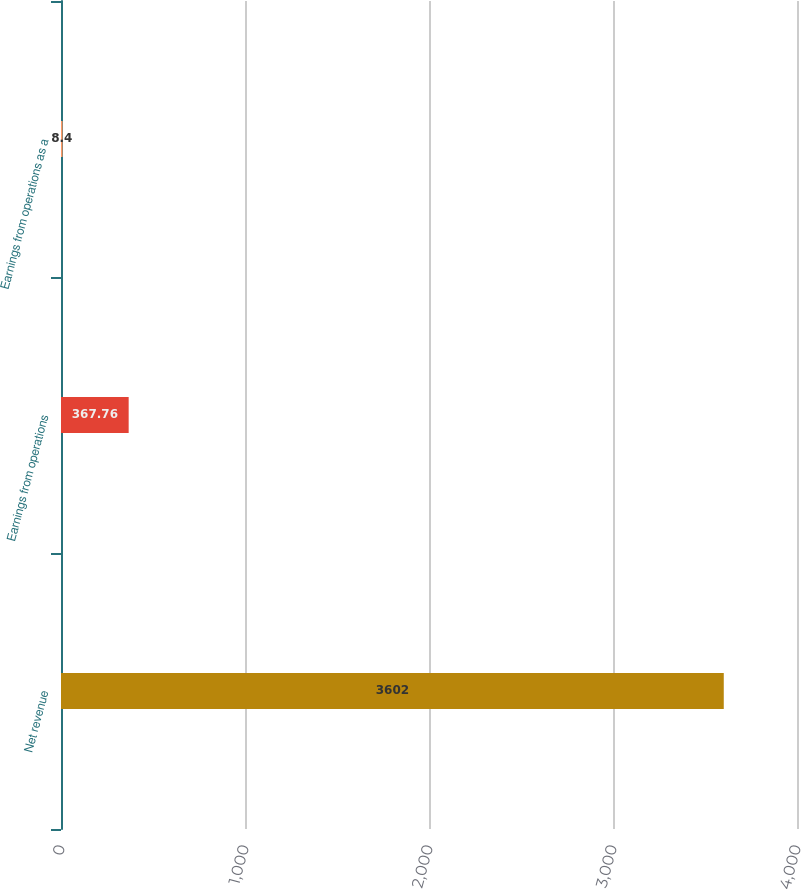<chart> <loc_0><loc_0><loc_500><loc_500><bar_chart><fcel>Net revenue<fcel>Earnings from operations<fcel>Earnings from operations as a<nl><fcel>3602<fcel>367.76<fcel>8.4<nl></chart> 